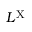Convert formula to latex. <formula><loc_0><loc_0><loc_500><loc_500>L ^ { X }</formula> 